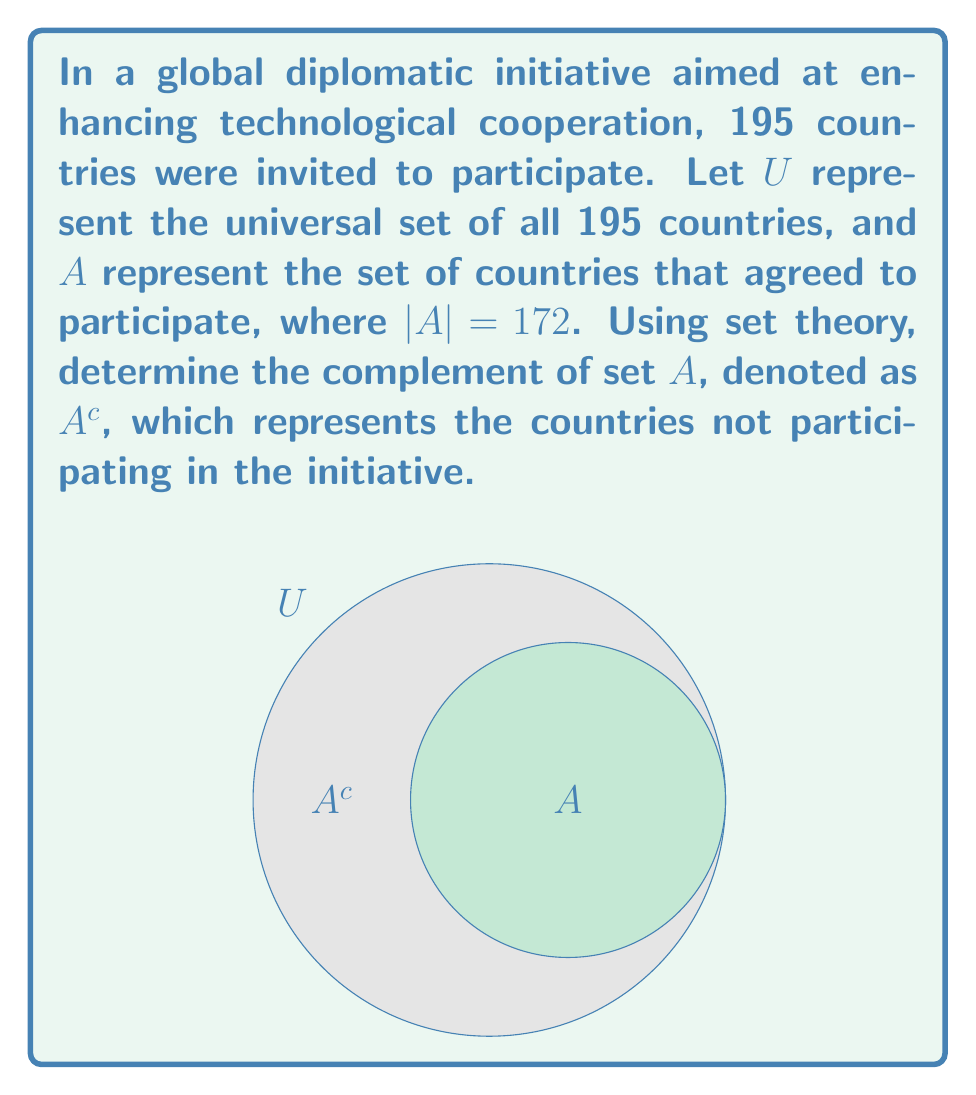Help me with this question. To find the complement of set $A$, we need to follow these steps:

1) First, recall that the complement of a set $A$ is defined as all elements in the universal set $U$ that are not in $A$. In set notation, this is written as:

   $A^c = U \setminus A$

2) We know that the universal set $U$ contains all 195 countries invited to the initiative.

3) We are given that $|A| = 172$, meaning 172 countries agreed to participate.

4) To find the number of countries in $A^c$, we need to subtract the number of countries in $A$ from the total number of countries in $U$:

   $|A^c| = |U| - |A|$

5) Substituting the known values:

   $|A^c| = 195 - 172 = 23$

6) Therefore, the complement of set $A$ contains 23 countries.

In the context of the diplomatic initiative, these 23 countries represent those that did not agree to participate in the technological cooperation effort.
Answer: $A^c = \{x \in U : x \notin A\}$, where $|A^c| = 23$ 